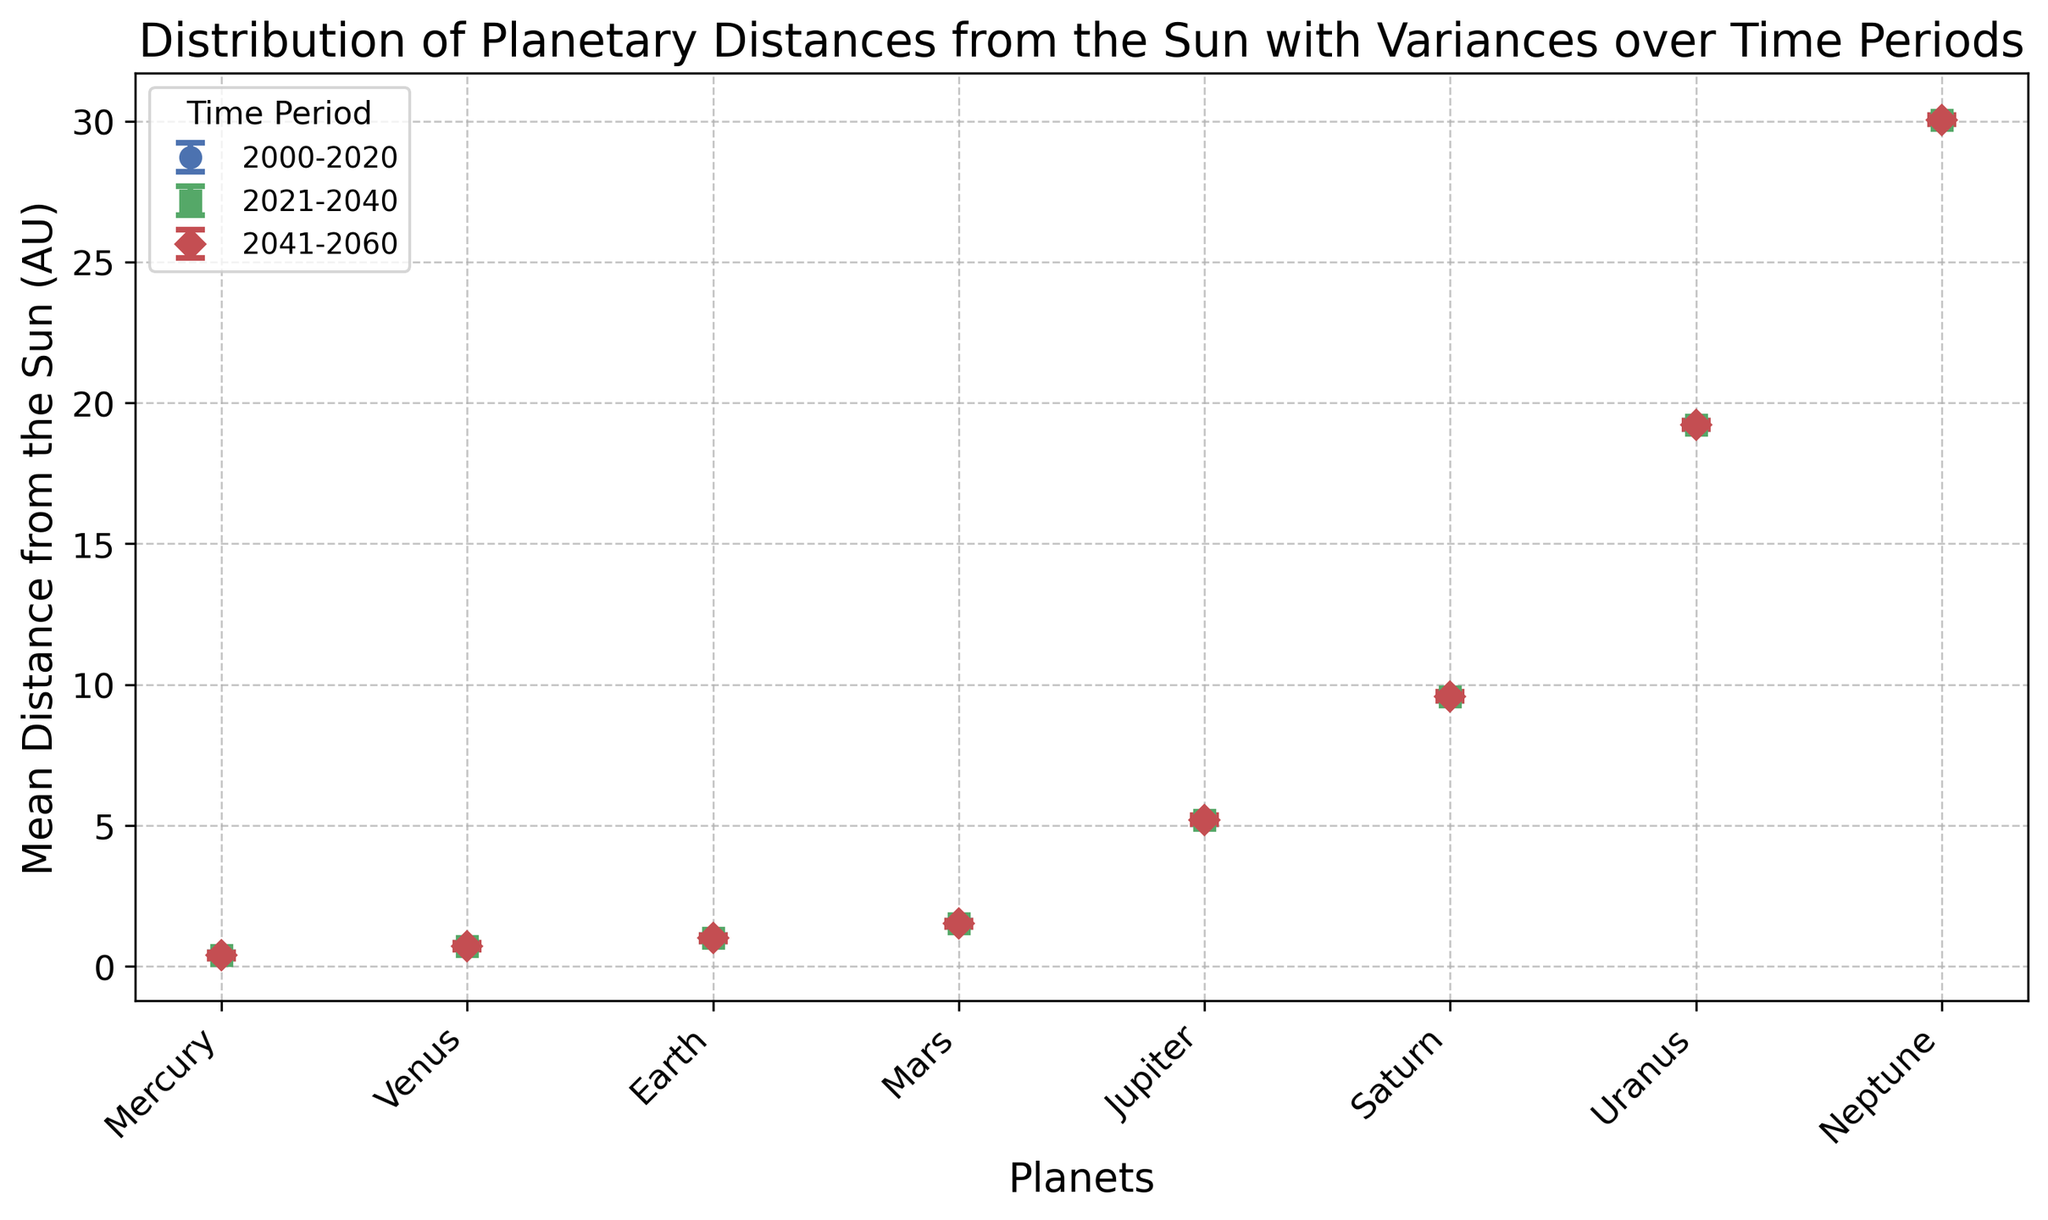Which planet has the largest mean distance from the Sun? Neptune is visually the farthest planet from the Sun in the plot, marked by the highest point along the y-axis.
Answer: Neptune Which time period shows the largest variance in distances for Uranus? The variance is represented by the size of the error bars. For Uranus, comparing the size of error bars across periods, the largest variance appears in 2000-2020.
Answer: 2000-2020 How does the mean distance of Mars compare between 2021-2040 and 2041-2060? Both periods show the mean distance value of Mars as 1.52 AU, indicating no difference between the periods.
Answer: The same Which planet exhibits the smallest change in variance across the time periods? By comparing the variances of all planets across time periods, we see that Mercury consistently shows the smallest changes in variance.
Answer: Mercury What is the sum of the mean distances of all planets for the 2041-2060 period? Summing the mean distances for all planets during 2041-2060: 0.39 (Mercury) + 0.72 (Venus) + 1.00 (Earth) + 1.52 (Mars) + 5.20 (Jupiter) + 9.58 (Saturn) + 19.22 (Uranus) + 30.05 (Neptune) = 67.68 AU
Answer: 67.68 AU Which planet's variance increased the most from 2000-2020 to 2041-2060? By calculating the increase in variance for each planet across these periods: 0.013 - 0.01 for Mercury, 0.013 - 0.01 for Venus, 0.013 - 0.01 for Earth, 0.013 - 0.01 for Mars, 0.025 - 0.02 for Jupiter, 0.025 - 0.02 for Saturn, 0.024 - 0.02 for Uranus, 0.024 - 0.02 for Neptune. The highest increase is for Jupiter, 0.005.
Answer: Jupiter How does the mean distance of the Earth compare to the mean distance of Venus across all time periods? Both planets' mean distances remain constant through all periods, Earth at 1.00 AU and Venus at 0.72 AU, meaning Earth is consistently farther from the Sun than Venus.
Answer: Earth > Venus What is the average of the variances for Neptune over all time periods? Summing the variances for Neptune across periods: 0.02 + 0.023 + 0.024 = 0.067. Dividing by the three periods to find the average: 0.067 / 3 = 0.0223.
Answer: 0.0223 Which time period has the highest mean distance for Jupiter? Jupiter's mean distance from the Sun remains constant at 5.20 AU across all periods, meaning no period has a higher mean distance than another.
Answer: All the same 